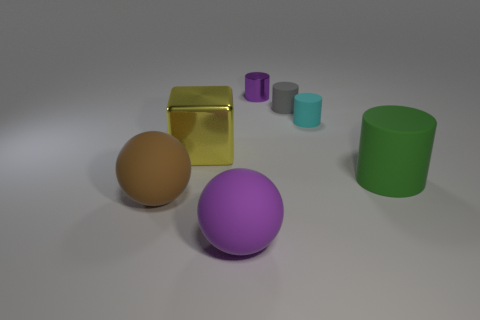Add 1 yellow matte blocks. How many objects exist? 8 Subtract 2 cylinders. How many cylinders are left? 2 Subtract all cyan cylinders. Subtract all gray cubes. How many cylinders are left? 3 Subtract all red cylinders. How many red cubes are left? 0 Subtract all large matte spheres. Subtract all brown matte spheres. How many objects are left? 4 Add 6 large shiny objects. How many large shiny objects are left? 7 Add 7 matte spheres. How many matte spheres exist? 9 Subtract all green cylinders. How many cylinders are left? 3 Subtract all rubber cylinders. How many cylinders are left? 1 Subtract 1 green cylinders. How many objects are left? 6 